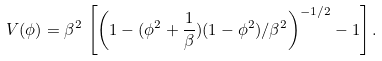Convert formula to latex. <formula><loc_0><loc_0><loc_500><loc_500>V ( \phi ) = \beta ^ { 2 } \, \left [ \left ( 1 - ( \phi ^ { 2 } + \frac { 1 } { \beta } ) ( 1 - \phi ^ { 2 } ) / \beta ^ { 2 } \right ) ^ { - 1 / 2 } - 1 \right ] .</formula> 